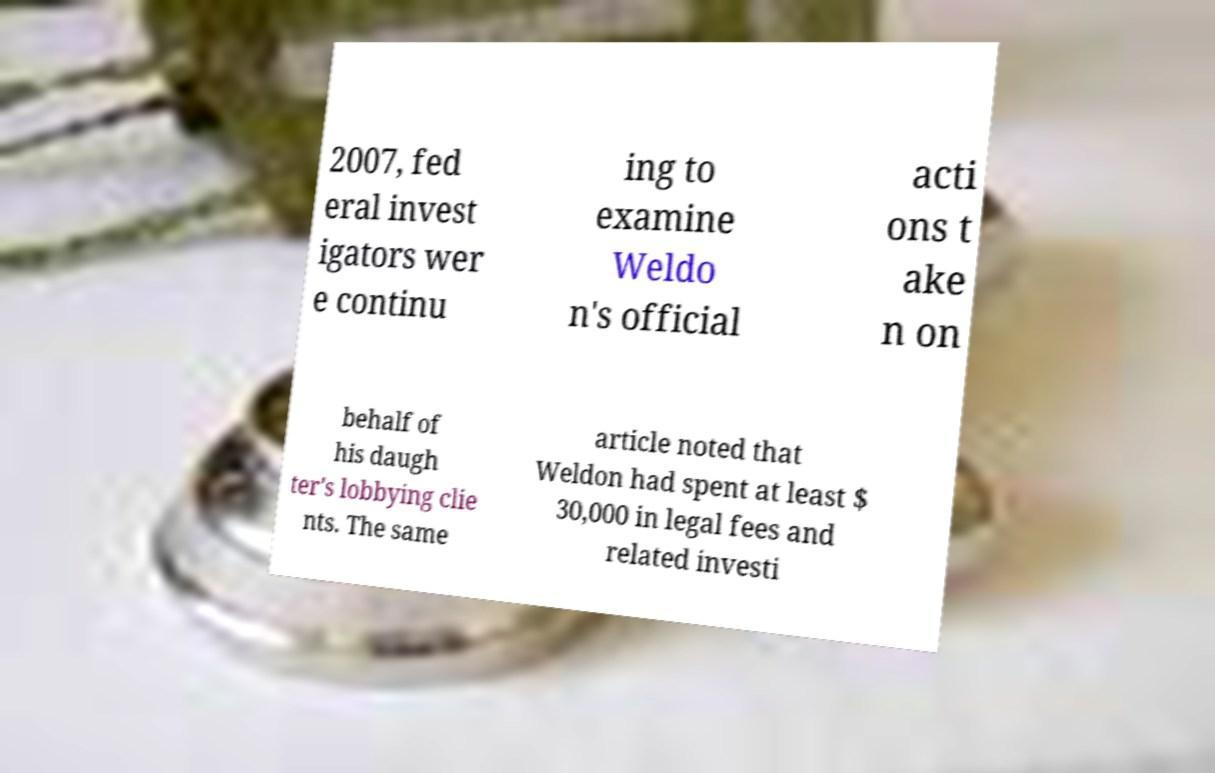For documentation purposes, I need the text within this image transcribed. Could you provide that? 2007, fed eral invest igators wer e continu ing to examine Weldo n's official acti ons t ake n on behalf of his daugh ter's lobbying clie nts. The same article noted that Weldon had spent at least $ 30,000 in legal fees and related investi 